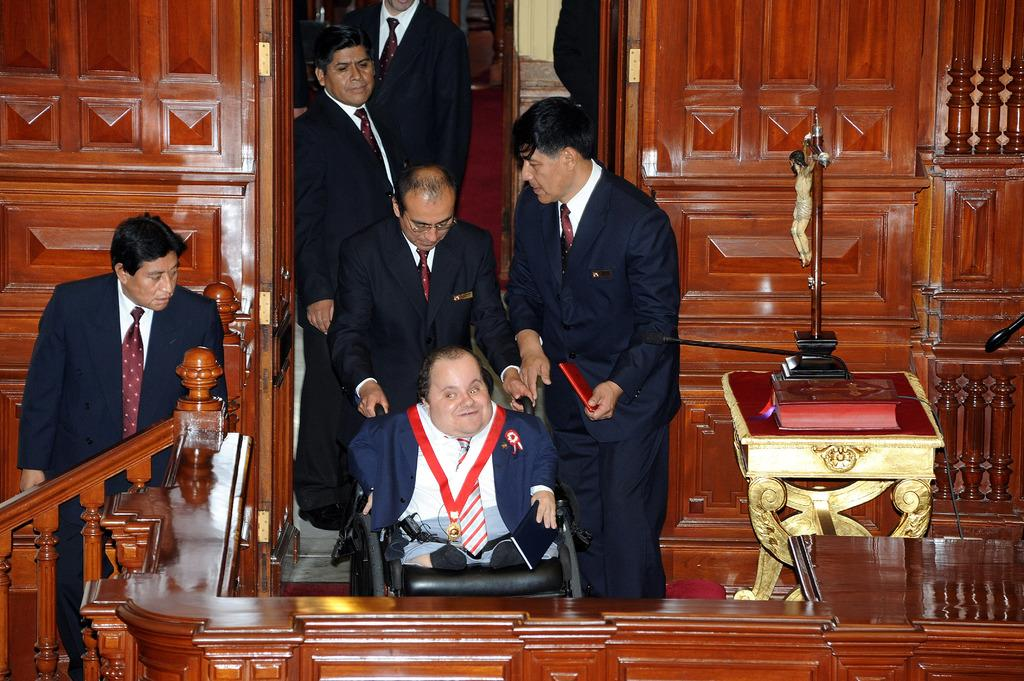Who or what can be seen in the image? There are people in the image. What is located on the right side of the image? There are objects on a table on the right side of the image. What type of wall is visible in the background of the image? There is a wooden wall in the background of the image. What type of books can be seen in the library in the image? There is no library present in the image, so it is not possible to determine what type of books might be seen. 